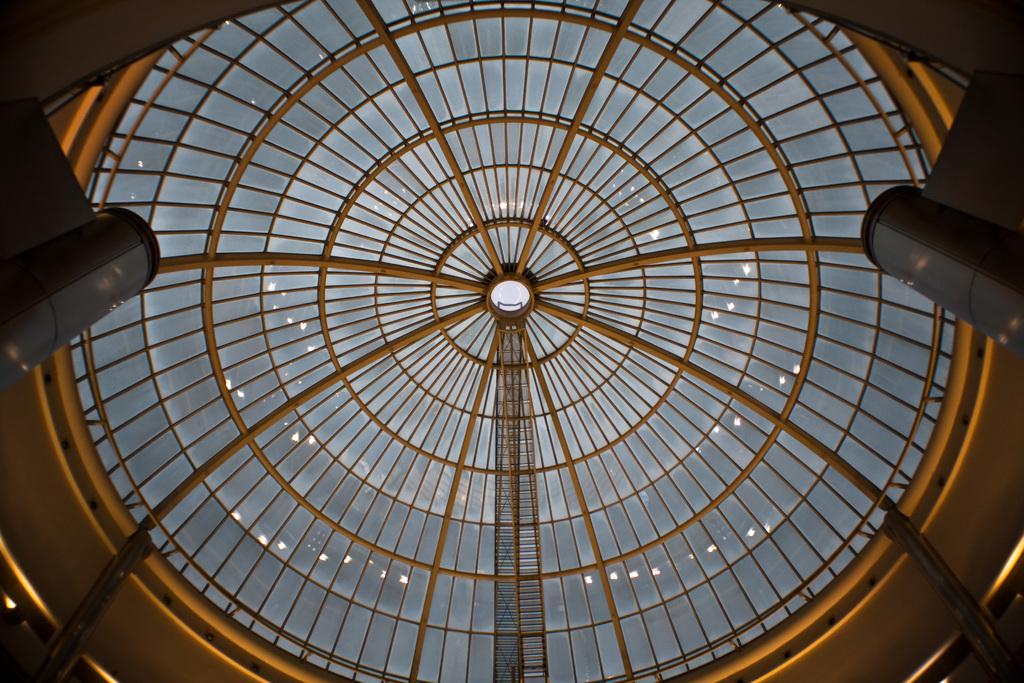What can be seen on the left side of the image? There are objects on the left side of the image. What can be seen on the right side of the image? There are objects on the right side of the image. What is the architectural feature in the background of the image? There is a glass roof in the background of the image. What else can be seen in the background of the image? There are poles and a wall in the background of the image. Can you tell me how many seeds are on the wall in the image? There are no seeds present on the wall in the image. What type of toe is visible in the image? There are no toes visible in the image. 